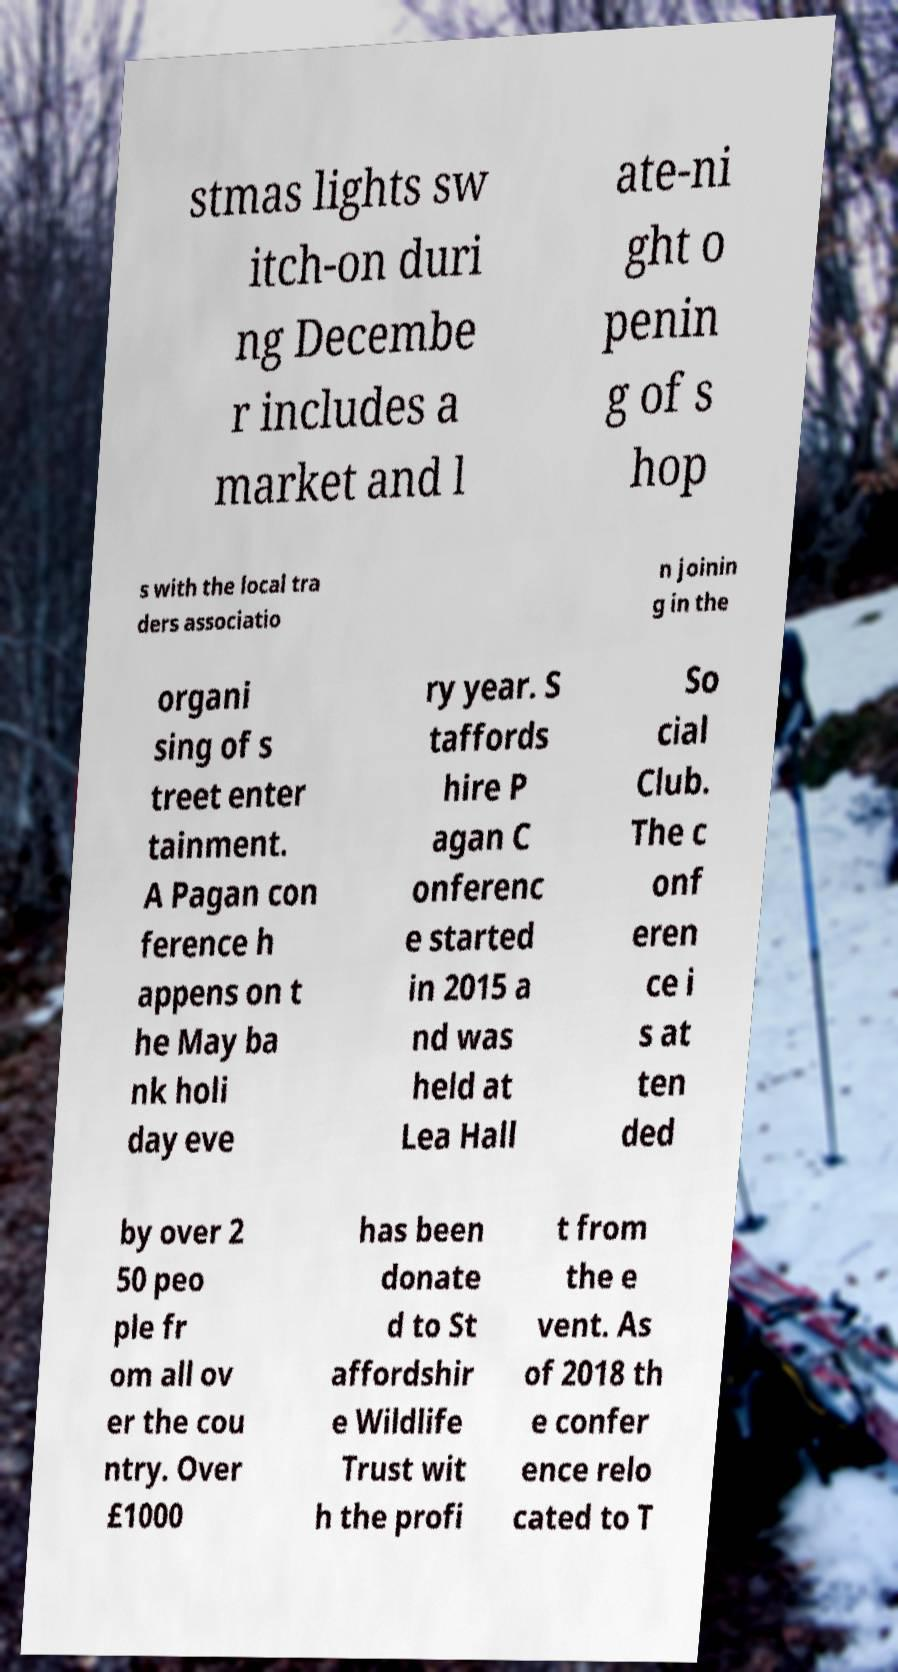Can you read and provide the text displayed in the image?This photo seems to have some interesting text. Can you extract and type it out for me? stmas lights sw itch-on duri ng Decembe r includes a market and l ate-ni ght o penin g of s hop s with the local tra ders associatio n joinin g in the organi sing of s treet enter tainment. A Pagan con ference h appens on t he May ba nk holi day eve ry year. S taffords hire P agan C onferenc e started in 2015 a nd was held at Lea Hall So cial Club. The c onf eren ce i s at ten ded by over 2 50 peo ple fr om all ov er the cou ntry. Over £1000 has been donate d to St affordshir e Wildlife Trust wit h the profi t from the e vent. As of 2018 th e confer ence relo cated to T 